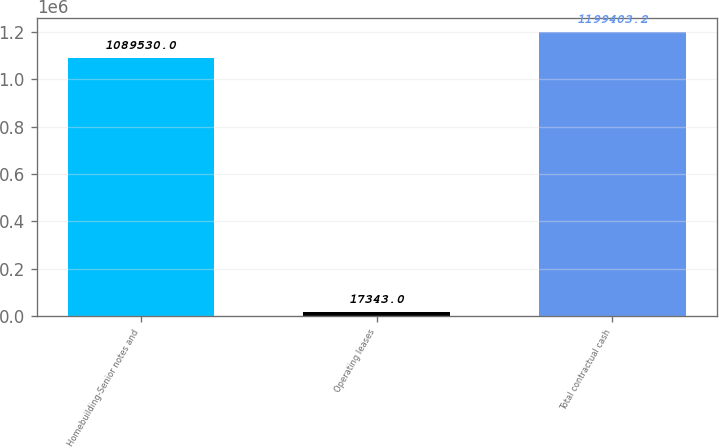Convert chart to OTSL. <chart><loc_0><loc_0><loc_500><loc_500><bar_chart><fcel>Homebuilding-Senior notes and<fcel>Operating leases<fcel>Total contractual cash<nl><fcel>1.08953e+06<fcel>17343<fcel>1.1994e+06<nl></chart> 